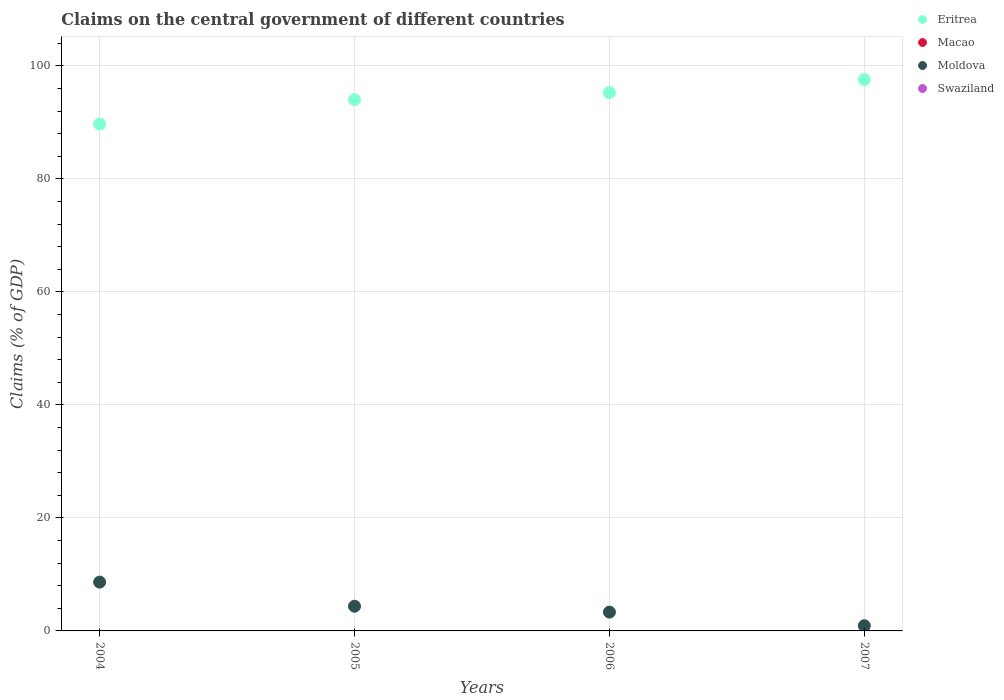What is the percentage of GDP claimed on the central government in Eritrea in 2007?
Offer a terse response. 97.6. Across all years, what is the maximum percentage of GDP claimed on the central government in Eritrea?
Ensure brevity in your answer.  97.6. Across all years, what is the minimum percentage of GDP claimed on the central government in Swaziland?
Make the answer very short. 0. In which year was the percentage of GDP claimed on the central government in Moldova maximum?
Your answer should be compact. 2004. What is the total percentage of GDP claimed on the central government in Macao in the graph?
Make the answer very short. 0. What is the difference between the percentage of GDP claimed on the central government in Eritrea in 2004 and that in 2006?
Provide a short and direct response. -5.56. What is the difference between the percentage of GDP claimed on the central government in Eritrea in 2004 and the percentage of GDP claimed on the central government in Moldova in 2005?
Make the answer very short. 85.35. In the year 2007, what is the difference between the percentage of GDP claimed on the central government in Eritrea and percentage of GDP claimed on the central government in Moldova?
Ensure brevity in your answer.  96.68. In how many years, is the percentage of GDP claimed on the central government in Macao greater than 16 %?
Keep it short and to the point. 0. What is the ratio of the percentage of GDP claimed on the central government in Moldova in 2005 to that in 2006?
Make the answer very short. 1.31. Is the difference between the percentage of GDP claimed on the central government in Eritrea in 2004 and 2006 greater than the difference between the percentage of GDP claimed on the central government in Moldova in 2004 and 2006?
Your response must be concise. No. What is the difference between the highest and the second highest percentage of GDP claimed on the central government in Moldova?
Keep it short and to the point. 4.27. What is the difference between the highest and the lowest percentage of GDP claimed on the central government in Eritrea?
Keep it short and to the point. 7.88. In how many years, is the percentage of GDP claimed on the central government in Moldova greater than the average percentage of GDP claimed on the central government in Moldova taken over all years?
Your response must be concise. 2. Is it the case that in every year, the sum of the percentage of GDP claimed on the central government in Swaziland and percentage of GDP claimed on the central government in Eritrea  is greater than the sum of percentage of GDP claimed on the central government in Moldova and percentage of GDP claimed on the central government in Macao?
Your answer should be compact. Yes. Is it the case that in every year, the sum of the percentage of GDP claimed on the central government in Eritrea and percentage of GDP claimed on the central government in Macao  is greater than the percentage of GDP claimed on the central government in Moldova?
Offer a terse response. Yes. Does the percentage of GDP claimed on the central government in Macao monotonically increase over the years?
Make the answer very short. No. Is the percentage of GDP claimed on the central government in Eritrea strictly less than the percentage of GDP claimed on the central government in Macao over the years?
Make the answer very short. No. How many dotlines are there?
Your answer should be very brief. 2. Where does the legend appear in the graph?
Provide a succinct answer. Top right. How many legend labels are there?
Make the answer very short. 4. How are the legend labels stacked?
Offer a terse response. Vertical. What is the title of the graph?
Ensure brevity in your answer.  Claims on the central government of different countries. Does "Belgium" appear as one of the legend labels in the graph?
Offer a very short reply. No. What is the label or title of the X-axis?
Your response must be concise. Years. What is the label or title of the Y-axis?
Keep it short and to the point. Claims (% of GDP). What is the Claims (% of GDP) of Eritrea in 2004?
Offer a very short reply. 89.72. What is the Claims (% of GDP) of Moldova in 2004?
Offer a very short reply. 8.64. What is the Claims (% of GDP) in Eritrea in 2005?
Offer a very short reply. 94.04. What is the Claims (% of GDP) of Moldova in 2005?
Your answer should be very brief. 4.37. What is the Claims (% of GDP) in Eritrea in 2006?
Offer a terse response. 95.28. What is the Claims (% of GDP) of Macao in 2006?
Provide a succinct answer. 0. What is the Claims (% of GDP) of Moldova in 2006?
Provide a succinct answer. 3.33. What is the Claims (% of GDP) of Swaziland in 2006?
Your answer should be very brief. 0. What is the Claims (% of GDP) of Eritrea in 2007?
Make the answer very short. 97.6. What is the Claims (% of GDP) in Moldova in 2007?
Ensure brevity in your answer.  0.92. What is the Claims (% of GDP) of Swaziland in 2007?
Your answer should be very brief. 0. Across all years, what is the maximum Claims (% of GDP) in Eritrea?
Offer a terse response. 97.6. Across all years, what is the maximum Claims (% of GDP) of Moldova?
Offer a very short reply. 8.64. Across all years, what is the minimum Claims (% of GDP) of Eritrea?
Provide a succinct answer. 89.72. Across all years, what is the minimum Claims (% of GDP) of Moldova?
Provide a succinct answer. 0.92. What is the total Claims (% of GDP) of Eritrea in the graph?
Keep it short and to the point. 376.64. What is the total Claims (% of GDP) in Macao in the graph?
Provide a succinct answer. 0. What is the total Claims (% of GDP) of Moldova in the graph?
Give a very brief answer. 17.26. What is the difference between the Claims (% of GDP) in Eritrea in 2004 and that in 2005?
Your answer should be very brief. -4.32. What is the difference between the Claims (% of GDP) in Moldova in 2004 and that in 2005?
Ensure brevity in your answer.  4.27. What is the difference between the Claims (% of GDP) of Eritrea in 2004 and that in 2006?
Your response must be concise. -5.56. What is the difference between the Claims (% of GDP) of Moldova in 2004 and that in 2006?
Make the answer very short. 5.31. What is the difference between the Claims (% of GDP) of Eritrea in 2004 and that in 2007?
Provide a succinct answer. -7.88. What is the difference between the Claims (% of GDP) in Moldova in 2004 and that in 2007?
Make the answer very short. 7.72. What is the difference between the Claims (% of GDP) of Eritrea in 2005 and that in 2006?
Give a very brief answer. -1.24. What is the difference between the Claims (% of GDP) of Moldova in 2005 and that in 2006?
Ensure brevity in your answer.  1.04. What is the difference between the Claims (% of GDP) of Eritrea in 2005 and that in 2007?
Provide a succinct answer. -3.56. What is the difference between the Claims (% of GDP) in Moldova in 2005 and that in 2007?
Your response must be concise. 3.45. What is the difference between the Claims (% of GDP) of Eritrea in 2006 and that in 2007?
Offer a terse response. -2.32. What is the difference between the Claims (% of GDP) of Moldova in 2006 and that in 2007?
Provide a short and direct response. 2.41. What is the difference between the Claims (% of GDP) of Eritrea in 2004 and the Claims (% of GDP) of Moldova in 2005?
Your answer should be compact. 85.35. What is the difference between the Claims (% of GDP) in Eritrea in 2004 and the Claims (% of GDP) in Moldova in 2006?
Keep it short and to the point. 86.39. What is the difference between the Claims (% of GDP) in Eritrea in 2004 and the Claims (% of GDP) in Moldova in 2007?
Keep it short and to the point. 88.8. What is the difference between the Claims (% of GDP) in Eritrea in 2005 and the Claims (% of GDP) in Moldova in 2006?
Offer a very short reply. 90.71. What is the difference between the Claims (% of GDP) of Eritrea in 2005 and the Claims (% of GDP) of Moldova in 2007?
Offer a very short reply. 93.12. What is the difference between the Claims (% of GDP) in Eritrea in 2006 and the Claims (% of GDP) in Moldova in 2007?
Offer a terse response. 94.36. What is the average Claims (% of GDP) of Eritrea per year?
Your response must be concise. 94.16. What is the average Claims (% of GDP) in Moldova per year?
Your response must be concise. 4.32. In the year 2004, what is the difference between the Claims (% of GDP) of Eritrea and Claims (% of GDP) of Moldova?
Make the answer very short. 81.08. In the year 2005, what is the difference between the Claims (% of GDP) in Eritrea and Claims (% of GDP) in Moldova?
Ensure brevity in your answer.  89.67. In the year 2006, what is the difference between the Claims (% of GDP) of Eritrea and Claims (% of GDP) of Moldova?
Offer a terse response. 91.95. In the year 2007, what is the difference between the Claims (% of GDP) of Eritrea and Claims (% of GDP) of Moldova?
Your response must be concise. 96.68. What is the ratio of the Claims (% of GDP) of Eritrea in 2004 to that in 2005?
Give a very brief answer. 0.95. What is the ratio of the Claims (% of GDP) of Moldova in 2004 to that in 2005?
Offer a terse response. 1.98. What is the ratio of the Claims (% of GDP) in Eritrea in 2004 to that in 2006?
Provide a short and direct response. 0.94. What is the ratio of the Claims (% of GDP) of Moldova in 2004 to that in 2006?
Offer a very short reply. 2.6. What is the ratio of the Claims (% of GDP) in Eritrea in 2004 to that in 2007?
Provide a short and direct response. 0.92. What is the ratio of the Claims (% of GDP) in Moldova in 2004 to that in 2007?
Give a very brief answer. 9.37. What is the ratio of the Claims (% of GDP) in Eritrea in 2005 to that in 2006?
Provide a short and direct response. 0.99. What is the ratio of the Claims (% of GDP) in Moldova in 2005 to that in 2006?
Ensure brevity in your answer.  1.31. What is the ratio of the Claims (% of GDP) of Eritrea in 2005 to that in 2007?
Your answer should be very brief. 0.96. What is the ratio of the Claims (% of GDP) of Moldova in 2005 to that in 2007?
Your answer should be very brief. 4.74. What is the ratio of the Claims (% of GDP) in Eritrea in 2006 to that in 2007?
Make the answer very short. 0.98. What is the ratio of the Claims (% of GDP) in Moldova in 2006 to that in 2007?
Offer a terse response. 3.61. What is the difference between the highest and the second highest Claims (% of GDP) in Eritrea?
Ensure brevity in your answer.  2.32. What is the difference between the highest and the second highest Claims (% of GDP) of Moldova?
Provide a short and direct response. 4.27. What is the difference between the highest and the lowest Claims (% of GDP) of Eritrea?
Provide a short and direct response. 7.88. What is the difference between the highest and the lowest Claims (% of GDP) of Moldova?
Your answer should be compact. 7.72. 